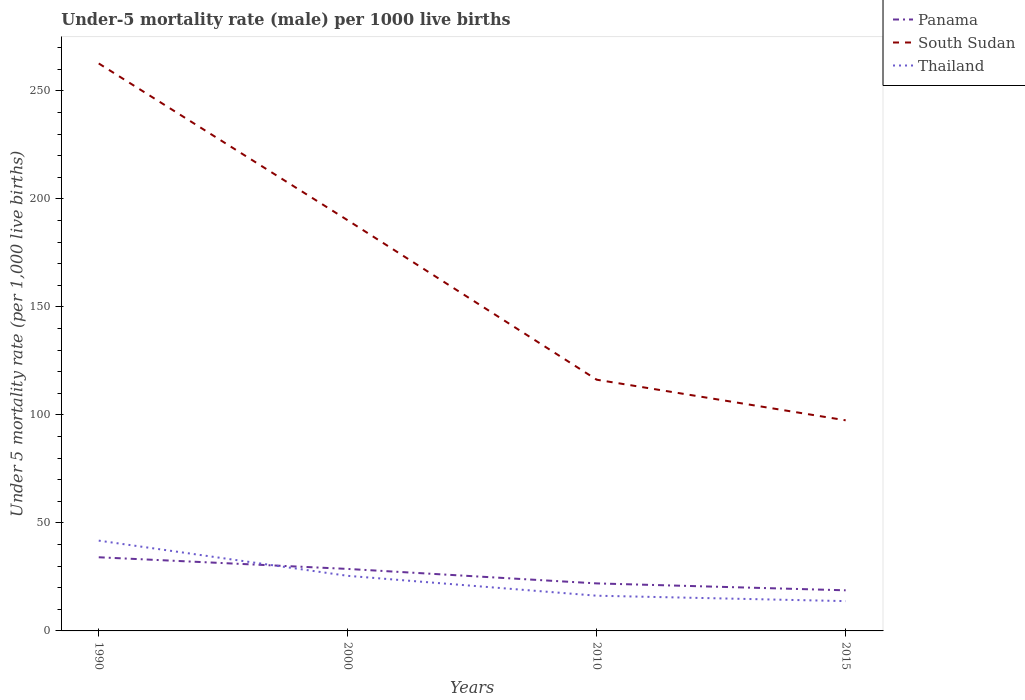In which year was the under-five mortality rate in Thailand maximum?
Provide a succinct answer. 2015. What is the total under-five mortality rate in Panama in the graph?
Ensure brevity in your answer.  5.4. What is the difference between the highest and the second highest under-five mortality rate in South Sudan?
Your answer should be compact. 165.2. What is the difference between the highest and the lowest under-five mortality rate in South Sudan?
Your answer should be compact. 2. How many lines are there?
Keep it short and to the point. 3. How many years are there in the graph?
Provide a short and direct response. 4. Does the graph contain grids?
Your answer should be compact. No. Where does the legend appear in the graph?
Your answer should be compact. Top right. How are the legend labels stacked?
Your answer should be very brief. Vertical. What is the title of the graph?
Provide a succinct answer. Under-5 mortality rate (male) per 1000 live births. Does "Burundi" appear as one of the legend labels in the graph?
Offer a very short reply. No. What is the label or title of the Y-axis?
Offer a very short reply. Under 5 mortality rate (per 1,0 live births). What is the Under 5 mortality rate (per 1,000 live births) in Panama in 1990?
Give a very brief answer. 34.1. What is the Under 5 mortality rate (per 1,000 live births) of South Sudan in 1990?
Your answer should be compact. 262.7. What is the Under 5 mortality rate (per 1,000 live births) in Thailand in 1990?
Provide a short and direct response. 41.8. What is the Under 5 mortality rate (per 1,000 live births) of Panama in 2000?
Your response must be concise. 28.7. What is the Under 5 mortality rate (per 1,000 live births) in South Sudan in 2000?
Provide a succinct answer. 190.1. What is the Under 5 mortality rate (per 1,000 live births) in South Sudan in 2010?
Your answer should be very brief. 116.3. What is the Under 5 mortality rate (per 1,000 live births) in Panama in 2015?
Provide a short and direct response. 18.8. What is the Under 5 mortality rate (per 1,000 live births) of South Sudan in 2015?
Give a very brief answer. 97.5. Across all years, what is the maximum Under 5 mortality rate (per 1,000 live births) in Panama?
Ensure brevity in your answer.  34.1. Across all years, what is the maximum Under 5 mortality rate (per 1,000 live births) of South Sudan?
Provide a succinct answer. 262.7. Across all years, what is the maximum Under 5 mortality rate (per 1,000 live births) in Thailand?
Offer a very short reply. 41.8. Across all years, what is the minimum Under 5 mortality rate (per 1,000 live births) in Panama?
Ensure brevity in your answer.  18.8. Across all years, what is the minimum Under 5 mortality rate (per 1,000 live births) in South Sudan?
Your answer should be very brief. 97.5. Across all years, what is the minimum Under 5 mortality rate (per 1,000 live births) of Thailand?
Your response must be concise. 13.8. What is the total Under 5 mortality rate (per 1,000 live births) in Panama in the graph?
Ensure brevity in your answer.  103.6. What is the total Under 5 mortality rate (per 1,000 live births) of South Sudan in the graph?
Your answer should be compact. 666.6. What is the total Under 5 mortality rate (per 1,000 live births) in Thailand in the graph?
Your response must be concise. 97.4. What is the difference between the Under 5 mortality rate (per 1,000 live births) of Panama in 1990 and that in 2000?
Provide a succinct answer. 5.4. What is the difference between the Under 5 mortality rate (per 1,000 live births) of South Sudan in 1990 and that in 2000?
Offer a terse response. 72.6. What is the difference between the Under 5 mortality rate (per 1,000 live births) in Thailand in 1990 and that in 2000?
Keep it short and to the point. 16.3. What is the difference between the Under 5 mortality rate (per 1,000 live births) in South Sudan in 1990 and that in 2010?
Offer a very short reply. 146.4. What is the difference between the Under 5 mortality rate (per 1,000 live births) of Thailand in 1990 and that in 2010?
Your response must be concise. 25.5. What is the difference between the Under 5 mortality rate (per 1,000 live births) of South Sudan in 1990 and that in 2015?
Give a very brief answer. 165.2. What is the difference between the Under 5 mortality rate (per 1,000 live births) of Thailand in 1990 and that in 2015?
Ensure brevity in your answer.  28. What is the difference between the Under 5 mortality rate (per 1,000 live births) in South Sudan in 2000 and that in 2010?
Provide a short and direct response. 73.8. What is the difference between the Under 5 mortality rate (per 1,000 live births) in Panama in 2000 and that in 2015?
Make the answer very short. 9.9. What is the difference between the Under 5 mortality rate (per 1,000 live births) in South Sudan in 2000 and that in 2015?
Offer a very short reply. 92.6. What is the difference between the Under 5 mortality rate (per 1,000 live births) in Thailand in 2000 and that in 2015?
Provide a short and direct response. 11.7. What is the difference between the Under 5 mortality rate (per 1,000 live births) in South Sudan in 2010 and that in 2015?
Provide a succinct answer. 18.8. What is the difference between the Under 5 mortality rate (per 1,000 live births) of Thailand in 2010 and that in 2015?
Make the answer very short. 2.5. What is the difference between the Under 5 mortality rate (per 1,000 live births) of Panama in 1990 and the Under 5 mortality rate (per 1,000 live births) of South Sudan in 2000?
Make the answer very short. -156. What is the difference between the Under 5 mortality rate (per 1,000 live births) in South Sudan in 1990 and the Under 5 mortality rate (per 1,000 live births) in Thailand in 2000?
Keep it short and to the point. 237.2. What is the difference between the Under 5 mortality rate (per 1,000 live births) of Panama in 1990 and the Under 5 mortality rate (per 1,000 live births) of South Sudan in 2010?
Your answer should be very brief. -82.2. What is the difference between the Under 5 mortality rate (per 1,000 live births) of South Sudan in 1990 and the Under 5 mortality rate (per 1,000 live births) of Thailand in 2010?
Offer a terse response. 246.4. What is the difference between the Under 5 mortality rate (per 1,000 live births) in Panama in 1990 and the Under 5 mortality rate (per 1,000 live births) in South Sudan in 2015?
Keep it short and to the point. -63.4. What is the difference between the Under 5 mortality rate (per 1,000 live births) of Panama in 1990 and the Under 5 mortality rate (per 1,000 live births) of Thailand in 2015?
Make the answer very short. 20.3. What is the difference between the Under 5 mortality rate (per 1,000 live births) in South Sudan in 1990 and the Under 5 mortality rate (per 1,000 live births) in Thailand in 2015?
Your response must be concise. 248.9. What is the difference between the Under 5 mortality rate (per 1,000 live births) in Panama in 2000 and the Under 5 mortality rate (per 1,000 live births) in South Sudan in 2010?
Your answer should be compact. -87.6. What is the difference between the Under 5 mortality rate (per 1,000 live births) in South Sudan in 2000 and the Under 5 mortality rate (per 1,000 live births) in Thailand in 2010?
Your response must be concise. 173.8. What is the difference between the Under 5 mortality rate (per 1,000 live births) in Panama in 2000 and the Under 5 mortality rate (per 1,000 live births) in South Sudan in 2015?
Make the answer very short. -68.8. What is the difference between the Under 5 mortality rate (per 1,000 live births) in Panama in 2000 and the Under 5 mortality rate (per 1,000 live births) in Thailand in 2015?
Your answer should be very brief. 14.9. What is the difference between the Under 5 mortality rate (per 1,000 live births) of South Sudan in 2000 and the Under 5 mortality rate (per 1,000 live births) of Thailand in 2015?
Your answer should be compact. 176.3. What is the difference between the Under 5 mortality rate (per 1,000 live births) of Panama in 2010 and the Under 5 mortality rate (per 1,000 live births) of South Sudan in 2015?
Your answer should be compact. -75.5. What is the difference between the Under 5 mortality rate (per 1,000 live births) in Panama in 2010 and the Under 5 mortality rate (per 1,000 live births) in Thailand in 2015?
Your response must be concise. 8.2. What is the difference between the Under 5 mortality rate (per 1,000 live births) of South Sudan in 2010 and the Under 5 mortality rate (per 1,000 live births) of Thailand in 2015?
Provide a succinct answer. 102.5. What is the average Under 5 mortality rate (per 1,000 live births) of Panama per year?
Offer a very short reply. 25.9. What is the average Under 5 mortality rate (per 1,000 live births) in South Sudan per year?
Your response must be concise. 166.65. What is the average Under 5 mortality rate (per 1,000 live births) of Thailand per year?
Your answer should be very brief. 24.35. In the year 1990, what is the difference between the Under 5 mortality rate (per 1,000 live births) of Panama and Under 5 mortality rate (per 1,000 live births) of South Sudan?
Offer a very short reply. -228.6. In the year 1990, what is the difference between the Under 5 mortality rate (per 1,000 live births) in South Sudan and Under 5 mortality rate (per 1,000 live births) in Thailand?
Provide a short and direct response. 220.9. In the year 2000, what is the difference between the Under 5 mortality rate (per 1,000 live births) of Panama and Under 5 mortality rate (per 1,000 live births) of South Sudan?
Give a very brief answer. -161.4. In the year 2000, what is the difference between the Under 5 mortality rate (per 1,000 live births) of South Sudan and Under 5 mortality rate (per 1,000 live births) of Thailand?
Provide a succinct answer. 164.6. In the year 2010, what is the difference between the Under 5 mortality rate (per 1,000 live births) of Panama and Under 5 mortality rate (per 1,000 live births) of South Sudan?
Offer a terse response. -94.3. In the year 2010, what is the difference between the Under 5 mortality rate (per 1,000 live births) in South Sudan and Under 5 mortality rate (per 1,000 live births) in Thailand?
Give a very brief answer. 100. In the year 2015, what is the difference between the Under 5 mortality rate (per 1,000 live births) of Panama and Under 5 mortality rate (per 1,000 live births) of South Sudan?
Your response must be concise. -78.7. In the year 2015, what is the difference between the Under 5 mortality rate (per 1,000 live births) of South Sudan and Under 5 mortality rate (per 1,000 live births) of Thailand?
Provide a succinct answer. 83.7. What is the ratio of the Under 5 mortality rate (per 1,000 live births) in Panama in 1990 to that in 2000?
Ensure brevity in your answer.  1.19. What is the ratio of the Under 5 mortality rate (per 1,000 live births) in South Sudan in 1990 to that in 2000?
Keep it short and to the point. 1.38. What is the ratio of the Under 5 mortality rate (per 1,000 live births) in Thailand in 1990 to that in 2000?
Ensure brevity in your answer.  1.64. What is the ratio of the Under 5 mortality rate (per 1,000 live births) in Panama in 1990 to that in 2010?
Your response must be concise. 1.55. What is the ratio of the Under 5 mortality rate (per 1,000 live births) in South Sudan in 1990 to that in 2010?
Offer a terse response. 2.26. What is the ratio of the Under 5 mortality rate (per 1,000 live births) of Thailand in 1990 to that in 2010?
Offer a terse response. 2.56. What is the ratio of the Under 5 mortality rate (per 1,000 live births) in Panama in 1990 to that in 2015?
Offer a terse response. 1.81. What is the ratio of the Under 5 mortality rate (per 1,000 live births) of South Sudan in 1990 to that in 2015?
Your response must be concise. 2.69. What is the ratio of the Under 5 mortality rate (per 1,000 live births) in Thailand in 1990 to that in 2015?
Give a very brief answer. 3.03. What is the ratio of the Under 5 mortality rate (per 1,000 live births) of Panama in 2000 to that in 2010?
Provide a succinct answer. 1.3. What is the ratio of the Under 5 mortality rate (per 1,000 live births) in South Sudan in 2000 to that in 2010?
Provide a succinct answer. 1.63. What is the ratio of the Under 5 mortality rate (per 1,000 live births) in Thailand in 2000 to that in 2010?
Provide a short and direct response. 1.56. What is the ratio of the Under 5 mortality rate (per 1,000 live births) in Panama in 2000 to that in 2015?
Offer a very short reply. 1.53. What is the ratio of the Under 5 mortality rate (per 1,000 live births) in South Sudan in 2000 to that in 2015?
Your response must be concise. 1.95. What is the ratio of the Under 5 mortality rate (per 1,000 live births) in Thailand in 2000 to that in 2015?
Offer a terse response. 1.85. What is the ratio of the Under 5 mortality rate (per 1,000 live births) in Panama in 2010 to that in 2015?
Ensure brevity in your answer.  1.17. What is the ratio of the Under 5 mortality rate (per 1,000 live births) of South Sudan in 2010 to that in 2015?
Your response must be concise. 1.19. What is the ratio of the Under 5 mortality rate (per 1,000 live births) in Thailand in 2010 to that in 2015?
Provide a succinct answer. 1.18. What is the difference between the highest and the second highest Under 5 mortality rate (per 1,000 live births) in South Sudan?
Your answer should be very brief. 72.6. What is the difference between the highest and the lowest Under 5 mortality rate (per 1,000 live births) in South Sudan?
Provide a succinct answer. 165.2. What is the difference between the highest and the lowest Under 5 mortality rate (per 1,000 live births) of Thailand?
Your answer should be very brief. 28. 